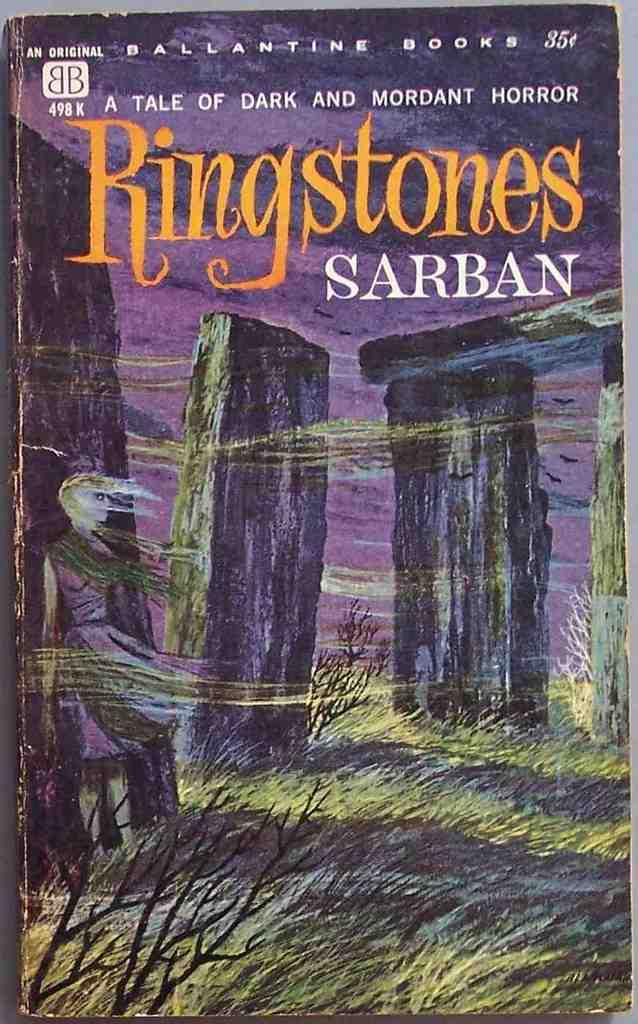<image>
Create a compact narrative representing the image presented. the name ringstones that is on a book 